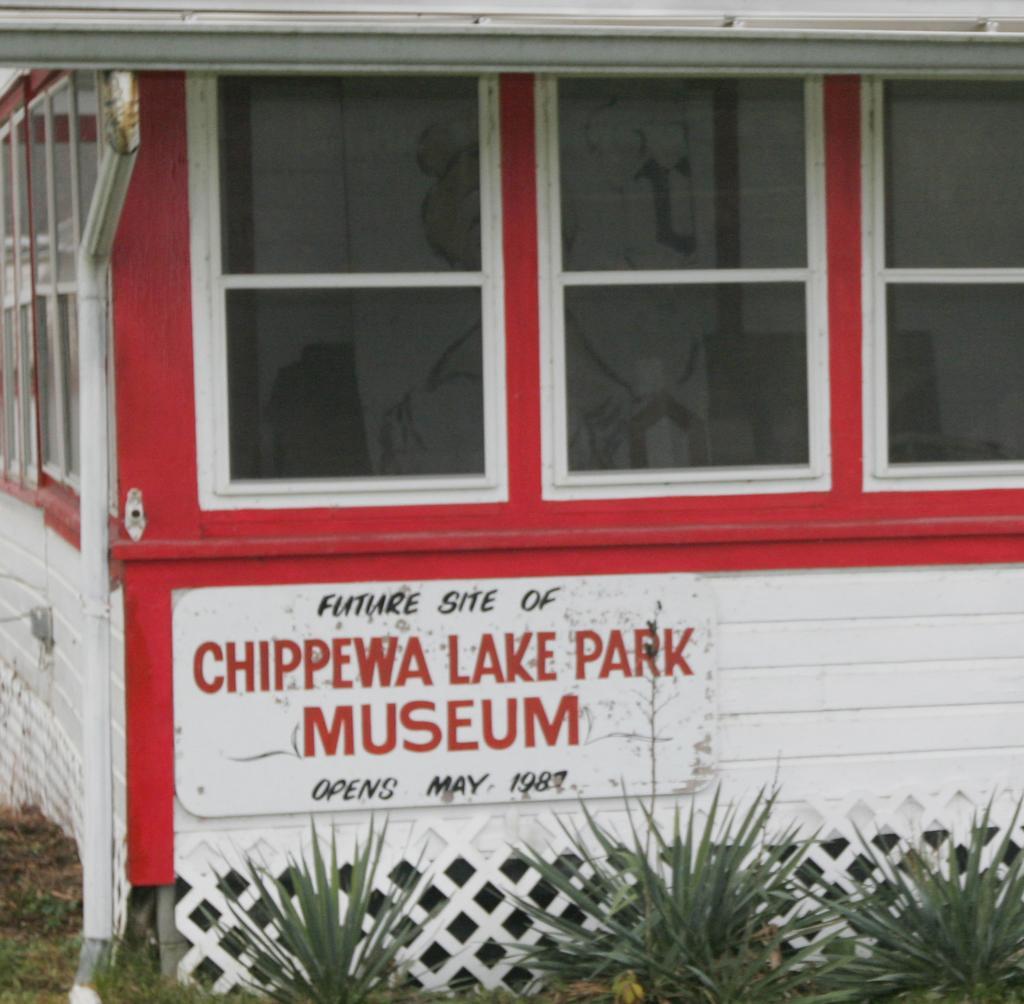Can you describe this image briefly? In this image I can see a building, windows, a pipe, few plants and here I can see something is written. 